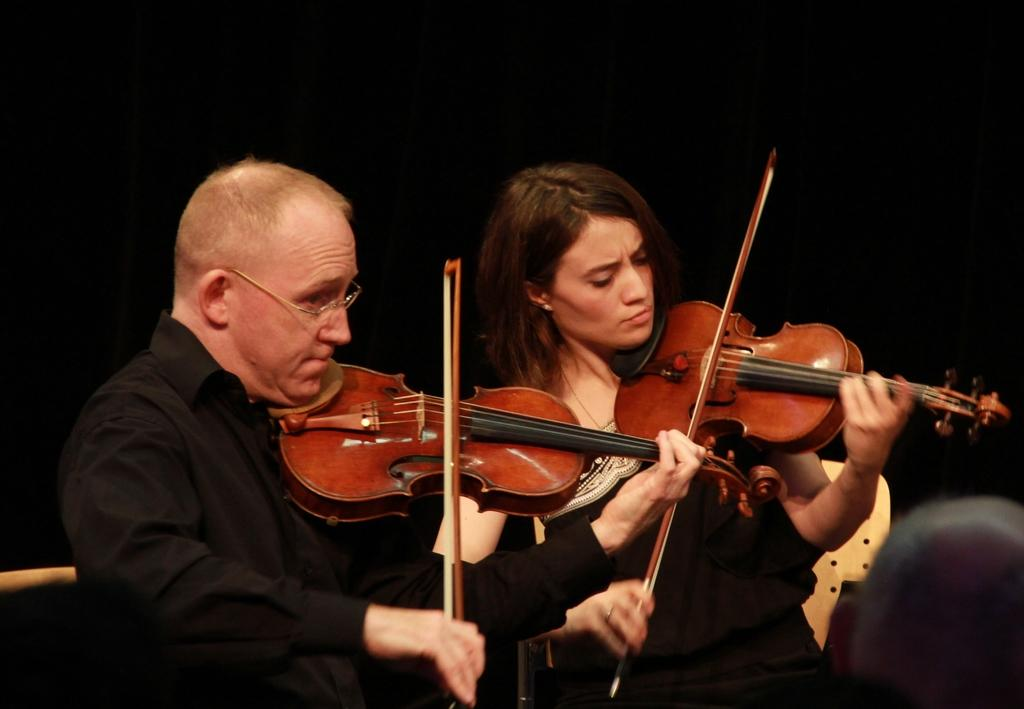How many people are in the image? There are two persons in the image. What are the two persons doing in the image? The two persons are playing a violin. What is the color of the background in the image? The background of the image is black in color. What type of jam can be seen on the railway tracks in the image? There is no railway or jam present in the image; it features two persons playing a violin with a black background. 